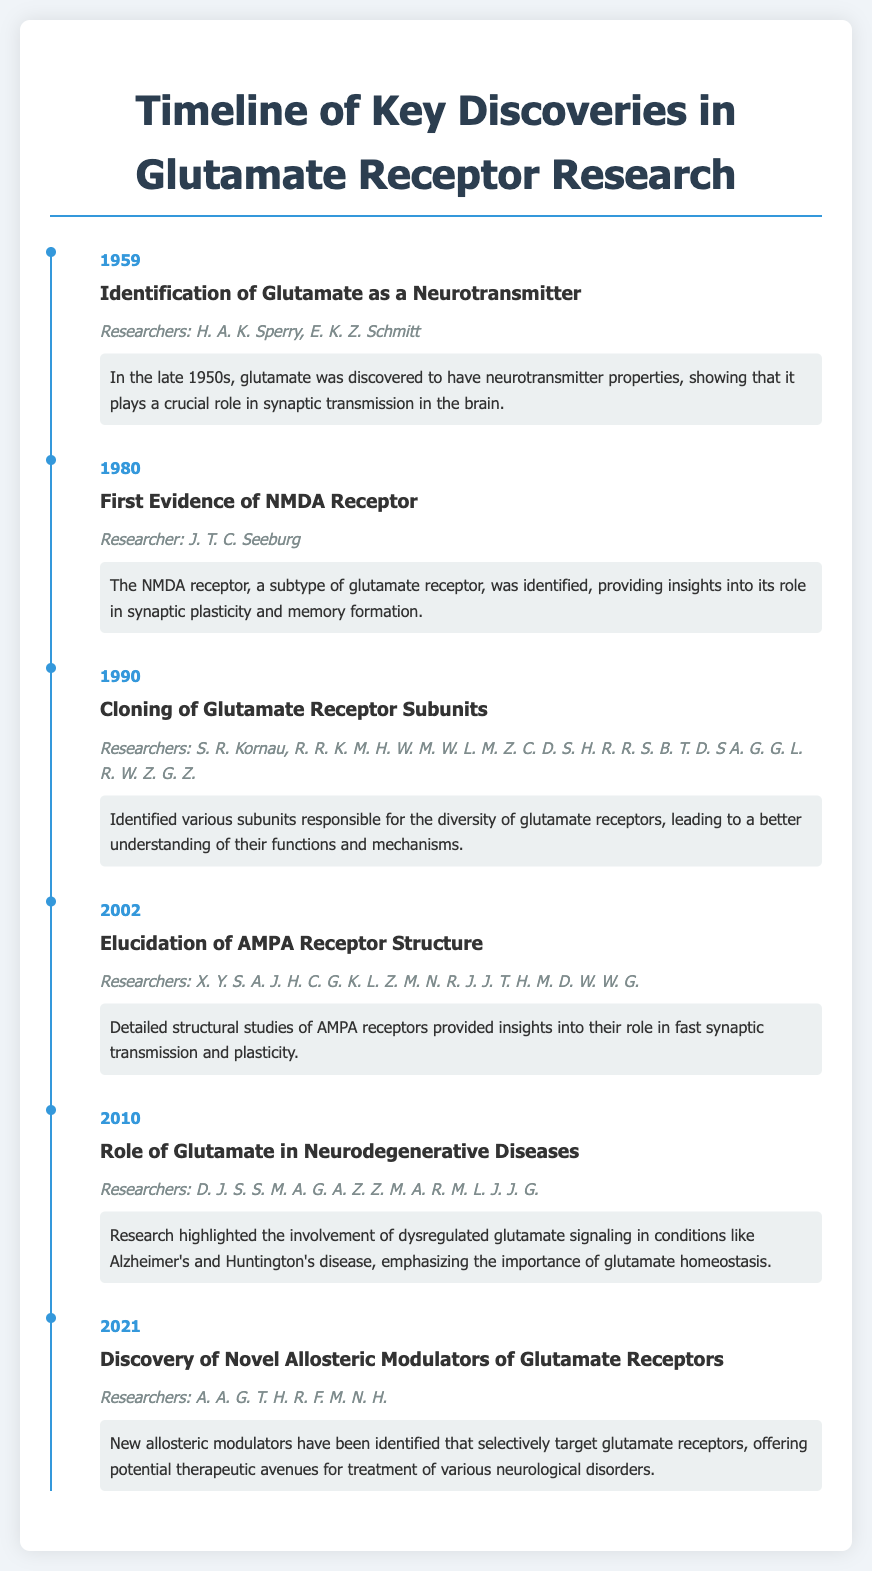What year was glutamate identified as a neurotransmitter? The year in which glutamate was identified as a neurotransmitter is explicitly stated in the document.
Answer: 1959 Who discovered the NMDA receptor? The document specifies the researcher associated with the first evidence of NMDA receptor.
Answer: J. T. C. Seeburg What significant discovery was made in 2002? The document lists the discoveries made in each year, including the elucidation of AMPA receptor structure in 2002.
Answer: Elucidation of AMPA Receptor Structure What role does glutamate play in neurodegenerative diseases according to the 2010 entry? The 2010 entry discusses glutamate's involvement in neurodegenerative diseases, hence the role mentioned in that section can be succinctly summarized.
Answer: Dysregulated glutamate signaling Which discovery was made most recently in the timeline? The document provides a chronological list of discoveries, identifying the latest one in 2021.
Answer: Discovery of Novel Allosteric Modulators of Glutamate Receptors In what context were glutamate receptor subunits cloned? The 1990 entry discusses the cloning of various subunits, providing insight into their function.
Answer: Diversity of glutamate receptors How many researchers are credited in the discovery of AMPA receptors in 2002? The number of researchers mentioned in the 2002 section can be counted from the provided names.
Answer: 11 What is a key topic discussed in the 2010 discovery? The section from 2010 discusses the importance of glutamate homeostasis in relation to neurodegenerative diseases.
Answer: Glutamate homeostasis 